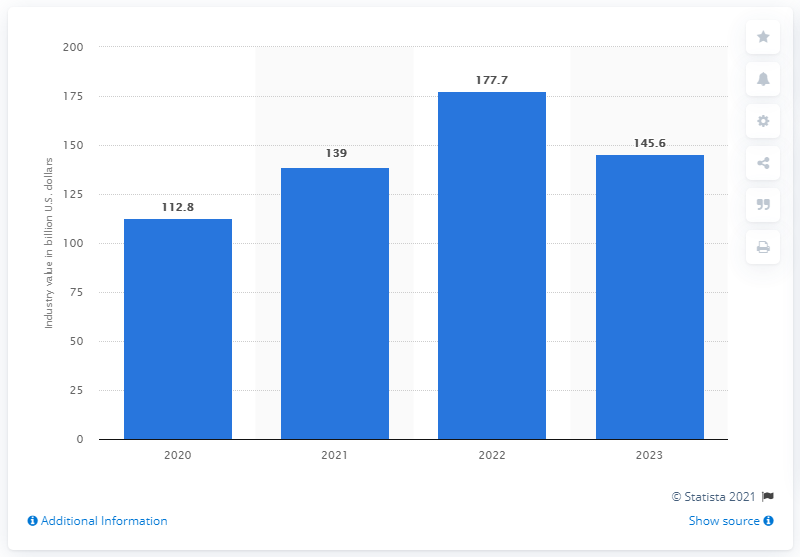Highlight a few significant elements in this photo. The global market for biofuels is projected to be valued at approximately 139 billion US dollars in 2021. 